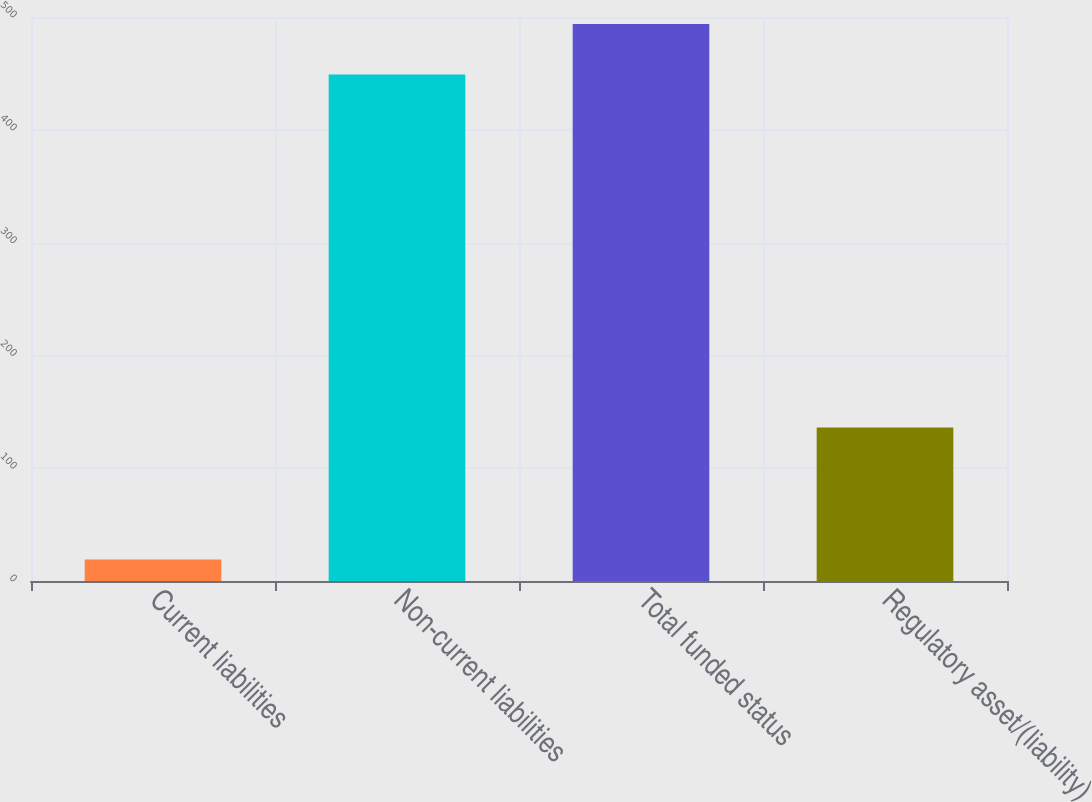<chart> <loc_0><loc_0><loc_500><loc_500><bar_chart><fcel>Current liabilities<fcel>Non-current liabilities<fcel>Total funded status<fcel>Regulatory asset/(liability)<nl><fcel>19<fcel>449<fcel>493.9<fcel>136<nl></chart> 